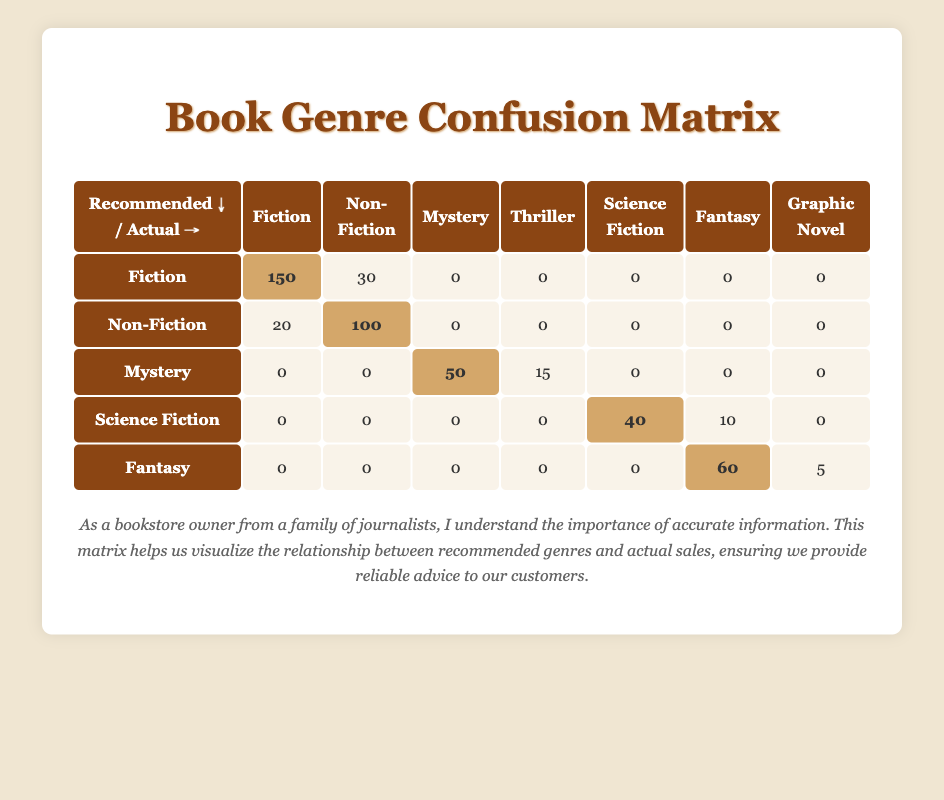What is the actual sales count for the Fiction genre when it is recommended? The table indicates that when Fiction is recommended, the actual sales count is highlighted as 150.
Answer: 150 How many Non-Fiction books were sold when Fiction was recommended? The table shows that when Fiction is recommended, the actual sales count for Non-Fiction is 30.
Answer: 30 What is the total actual sales count for Fantasy across all recommendations? To find the total for Fantasy, we look at the row where Fantasy is recommended: 60 (Fantasy) + 5 (Graphic Novel) = 65.
Answer: 65 Did more Mystery books sell than Thriller books when Mystery was recommended? The actual sales for Mystery when recommended is 50, while for Thriller it is 15. Since 50 > 15, the answer is Yes.
Answer: Yes How many books were sold in total for the Science Fiction genre when recommended? The Science Fiction row shows that when Science Fiction is recommended, the actual sales count is 40 for Science Fiction and 10 for Fantasy, making the total 40 + 10 = 50.
Answer: 50 What is the total number of actual sales for Non-Fiction books across all recommendations? Non-Fiction appears in two rows: 100 (when recommended as Non-Fiction) and 30 (when recommended as Fiction). Totaling these gives 100 + 30 = 130.
Answer: 130 Is there any case where more books were sold in a different genre compared to the recommended genre? Looking at the table, we see that when Non-Fiction is recommended, 100 were sold, whereas 20 were sold in Fiction, indicating not in that case.
Answer: No How many different genres were recommended that resulted in at least 50 actual sales? Analyzing the table, we find three cases of genres with 50 or more sales: Fiction (150), Non-Fiction (100), and Fantasy (60), thus there are three genres.
Answer: 3 Which recommended genre resulted in the least actual sales? By examining the table, we see that for recommended genres, both Graphic Novel and Thriller had sales of 5 and 15, respectively. Therefore, the least sales come from the case of Graphic Novel, with only 5.
Answer: 5 